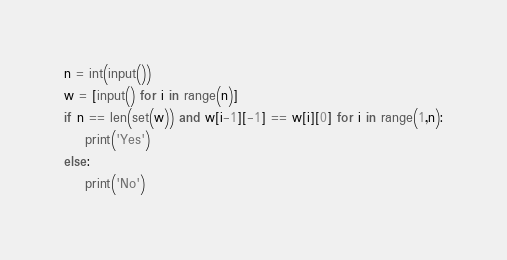Convert code to text. <code><loc_0><loc_0><loc_500><loc_500><_Python_>n = int(input())
w = [input() for i in range(n)]
if n == len(set(w)) and w[i-1][-1] == w[i][0] for i in range(1,n):
    print('Yes')
else:
    print('No')</code> 